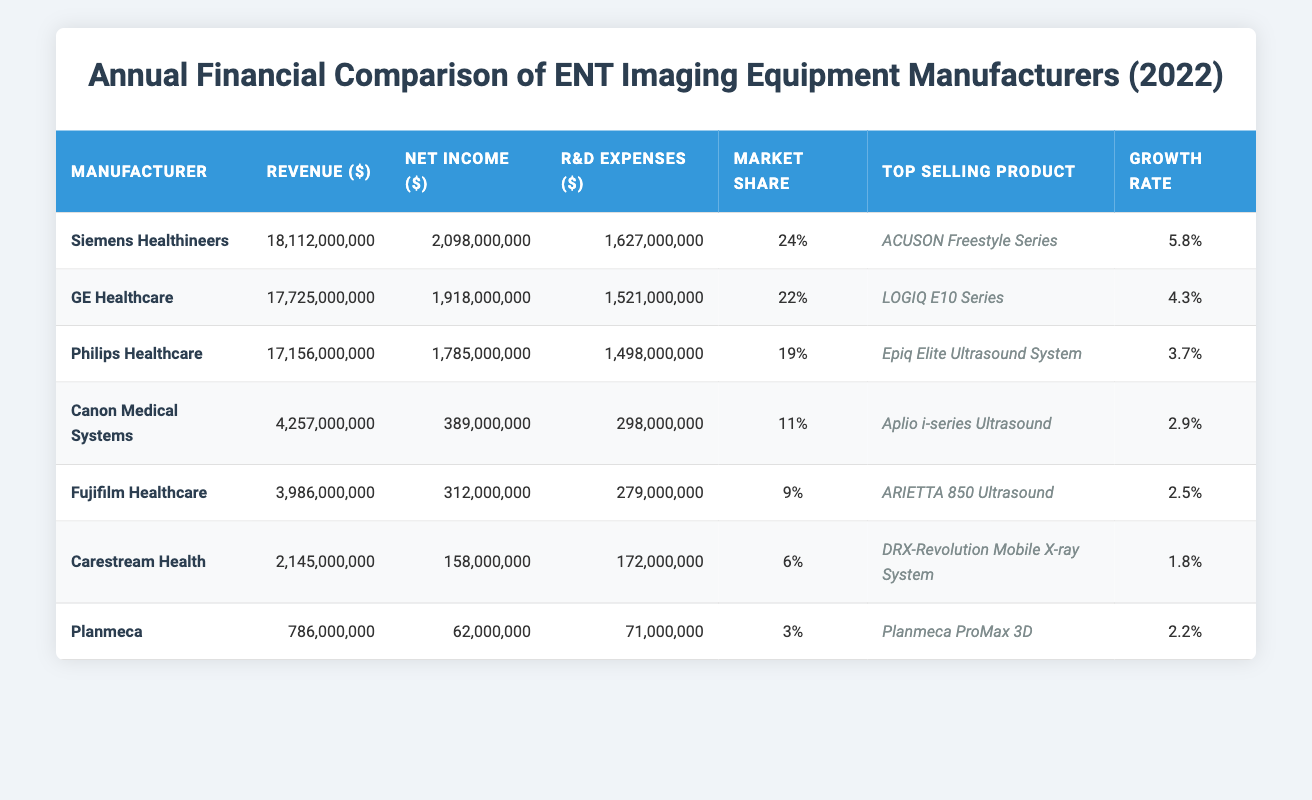What is the total revenue for all manufacturers combined? To find the total revenue, sum the revenue from each manufacturer: 18,112,000,000 + 17,725,000,000 + 17,156,000,000 + 4,257,000,000 + 3,986,000,000 + 2,145,000,000 + 786,000,000 = 63,167,000,000.
Answer: 63,167,000,000 Which manufacturer has the highest market share? The market shares listed are 24%, 22%, 19%, 11%, 9%, 6%, and 3%. The highest market share is 24%, which belongs to Siemens Healthineers.
Answer: Siemens Healthineers Did Canon Medical Systems have more revenue than Fujifilm Healthcare? Canon Medical Systems reported revenue of 4,257,000,000, while Fujifilm Healthcare had revenue of 3,986,000,000. Since 4,257,000,000 is greater than 3,986,000,000, the statement is true.
Answer: Yes What is the average R&D expenses for the manufacturers listed? To find the average R&D expenses, we add the R&D expenses: 1,627,000,000 + 1,521,000,000 + 1,498,000,000 + 298,000,000 + 279,000,000 + 172,000,000 + 71,000,000 = 5,466,000,000. Then, divide by the number of manufacturers (7), so 5,466,000,000 / 7 = 780,857,142.857, which we round to 780,857,143.
Answer: 780,857,143 Which company had a lower growth rate, Carestream Health or Planmeca? Carestream Health had a growth rate of 1.8% while Planmeca had a growth rate of 2.2%. Since 1.8% is less than 2.2%, Carestream Health had the lower growth rate.
Answer: Carestream Health What is the difference in net income between Siemens Healthineers and GE Healthcare? Siemens Healthineers had a net income of 2,098,000,000 and GE Healthcare had a net income of 1,918,000,000. The difference is calculated as 2,098,000,000 - 1,918,000,000 = 180,000,000.
Answer: 180,000,000 Is Philips Healthcare's top-selling product an ultrasound system? The top-selling product for Philips Healthcare is the Epiq Elite Ultrasound System, which indicates it is indeed an ultrasound system. Therefore, this statement is true.
Answer: Yes Which manufacturer had the lowest revenue? The revenues from the manufacturers are as follows: 18,112,000,000, 17,725,000,000, 17,156,000,000, 4,257,000,000, 3,986,000,000, 2,145,000,000, and 786,000,000. The lowest revenue is 786,000,000, which is Planmeca.
Answer: Planmeca What is the percentage difference in market share between Siemens Healthineers and GE Healthcare? Siemens Healthineers holds 24% market share and GE Healthcare holds 22%. The percentage difference is calculated as (24 - 22) = 2%.
Answer: 2% 